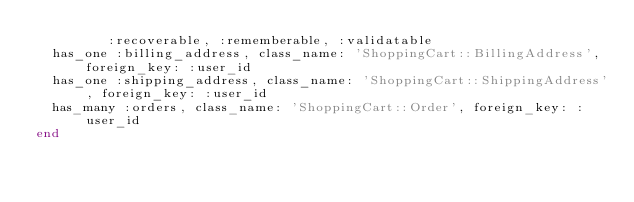<code> <loc_0><loc_0><loc_500><loc_500><_Ruby_>         :recoverable, :rememberable, :validatable
  has_one :billing_address, class_name: 'ShoppingCart::BillingAddress', foreign_key: :user_id
  has_one :shipping_address, class_name: 'ShoppingCart::ShippingAddress', foreign_key: :user_id
  has_many :orders, class_name: 'ShoppingCart::Order', foreign_key: :user_id
end
</code> 